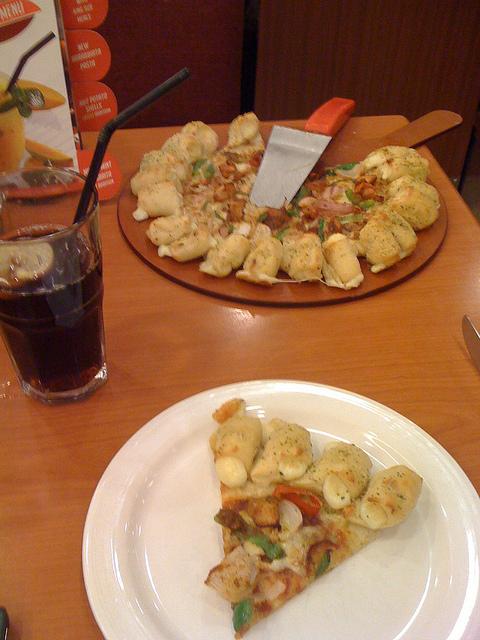What else is being eaten here besides pizza?
Quick response, please. Nothing. Is the plate white?
Concise answer only. Yes. What are the toppings on the pizza?
Quick response, please. Veggies. How many slices of pizza are on the white plate?
Answer briefly. 1. 